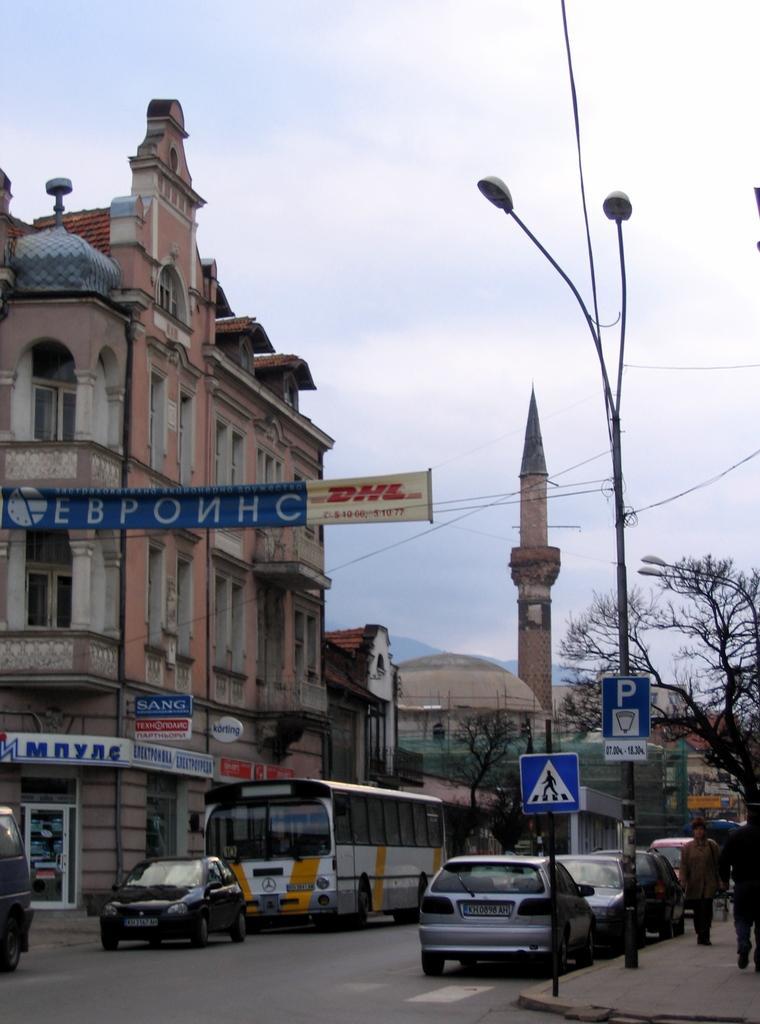Can you describe this image briefly? In this image I can see few vehicles on the road and I can also see few persons walking, few boards attached to the poles. In the background I can see few buildings in white and brown color and I can see few dried trees, few light poles and the sky is in white color. 